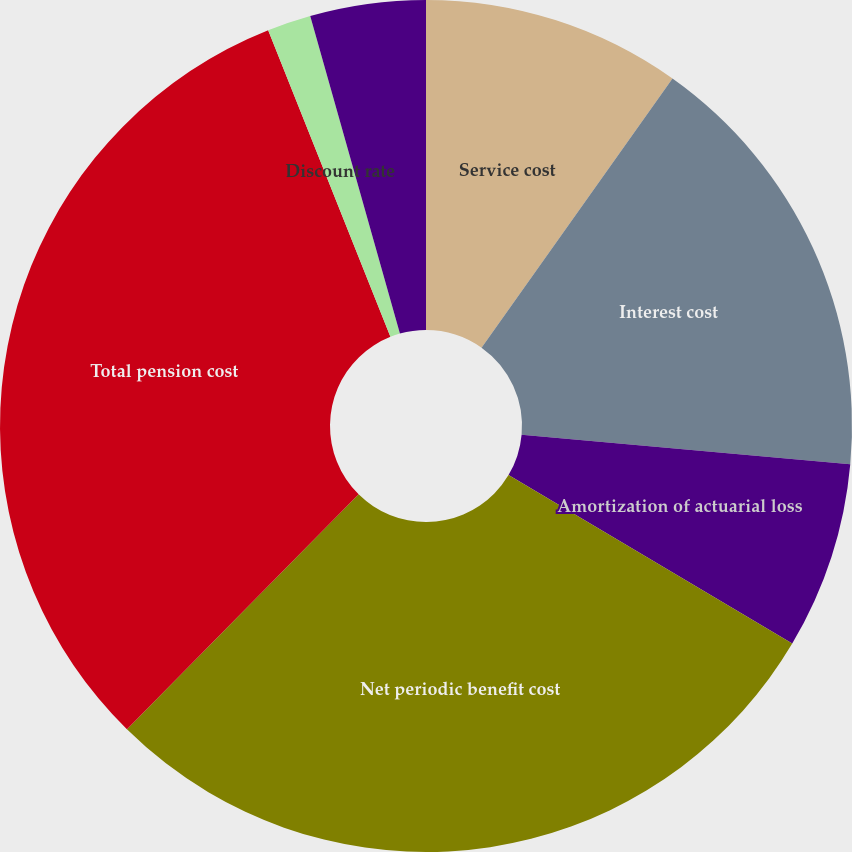Convert chart. <chart><loc_0><loc_0><loc_500><loc_500><pie_chart><fcel>Service cost<fcel>Interest cost<fcel>Amortization of actuarial loss<fcel>Net periodic benefit cost<fcel>Total pension cost<fcel>Discount rate<fcel>Long-term rate of return on<nl><fcel>9.82%<fcel>16.61%<fcel>7.1%<fcel>28.85%<fcel>31.57%<fcel>1.66%<fcel>4.38%<nl></chart> 